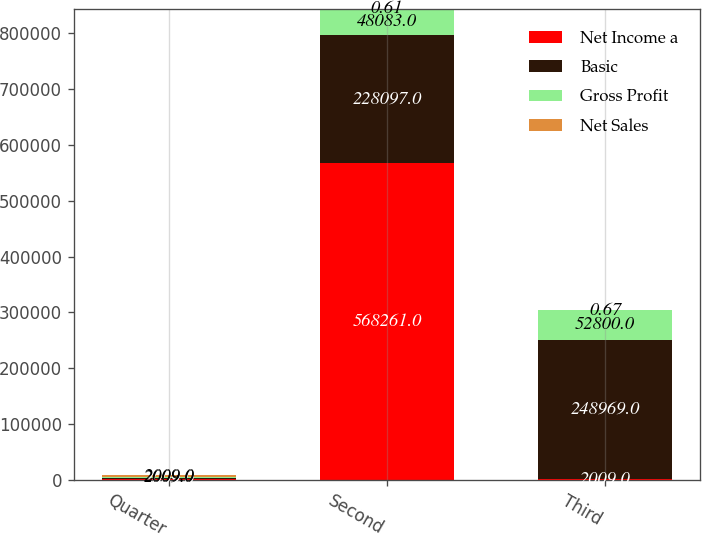<chart> <loc_0><loc_0><loc_500><loc_500><stacked_bar_chart><ecel><fcel>Quarter<fcel>Second<fcel>Third<nl><fcel>Net Income a<fcel>2009<fcel>568261<fcel>2009<nl><fcel>Basic<fcel>2009<fcel>228097<fcel>248969<nl><fcel>Gross Profit<fcel>2009<fcel>48083<fcel>52800<nl><fcel>Net Sales<fcel>2009<fcel>0.61<fcel>0.67<nl></chart> 